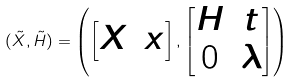<formula> <loc_0><loc_0><loc_500><loc_500>( \tilde { X } , \tilde { H } ) = \left ( \begin{bmatrix} X & x \end{bmatrix} , \begin{bmatrix} H & t \\ 0 & \lambda \end{bmatrix} \right )</formula> 